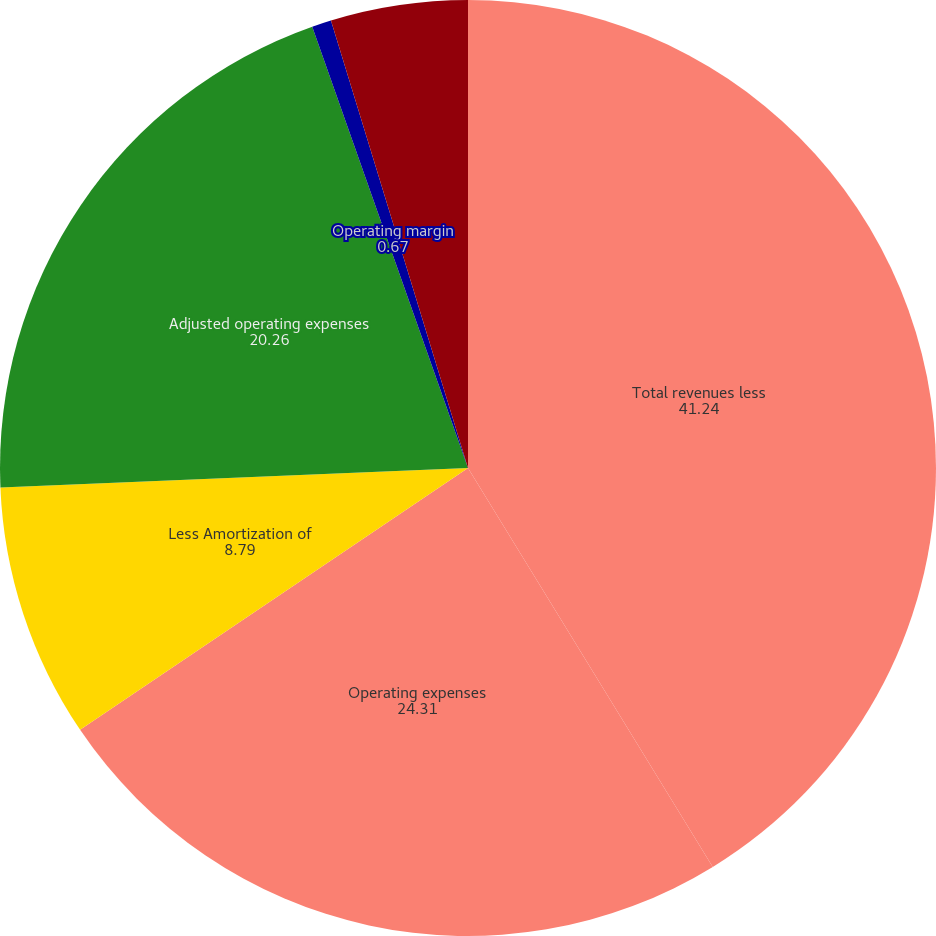<chart> <loc_0><loc_0><loc_500><loc_500><pie_chart><fcel>Total revenues less<fcel>Operating expenses<fcel>Less Amortization of<fcel>Adjusted operating expenses<fcel>Operating margin<fcel>Adjusted operating margin<nl><fcel>41.24%<fcel>24.31%<fcel>8.79%<fcel>20.26%<fcel>0.67%<fcel>4.73%<nl></chart> 